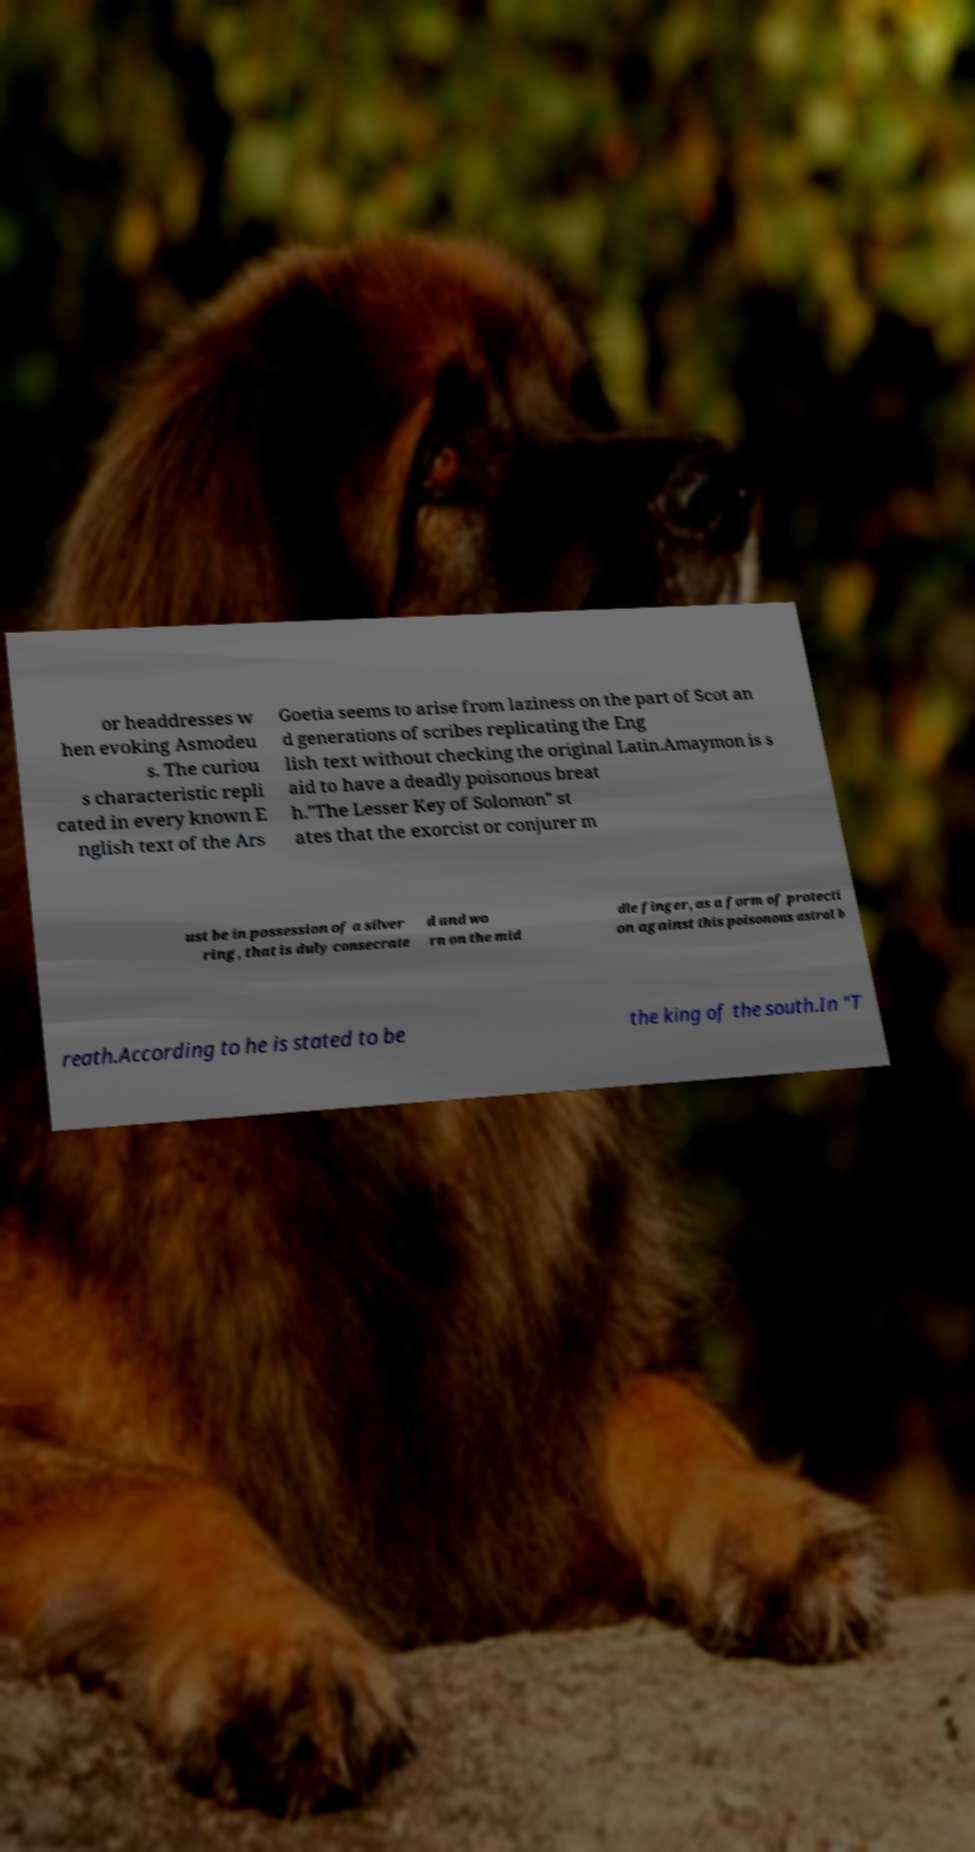For documentation purposes, I need the text within this image transcribed. Could you provide that? or headdresses w hen evoking Asmodeu s. The curiou s characteristic repli cated in every known E nglish text of the Ars Goetia seems to arise from laziness on the part of Scot an d generations of scribes replicating the Eng lish text without checking the original Latin.Amaymon is s aid to have a deadly poisonous breat h."The Lesser Key of Solomon" st ates that the exorcist or conjurer m ust be in possession of a silver ring, that is duly consecrate d and wo rn on the mid dle finger, as a form of protecti on against this poisonous astral b reath.According to he is stated to be the king of the south.In "T 